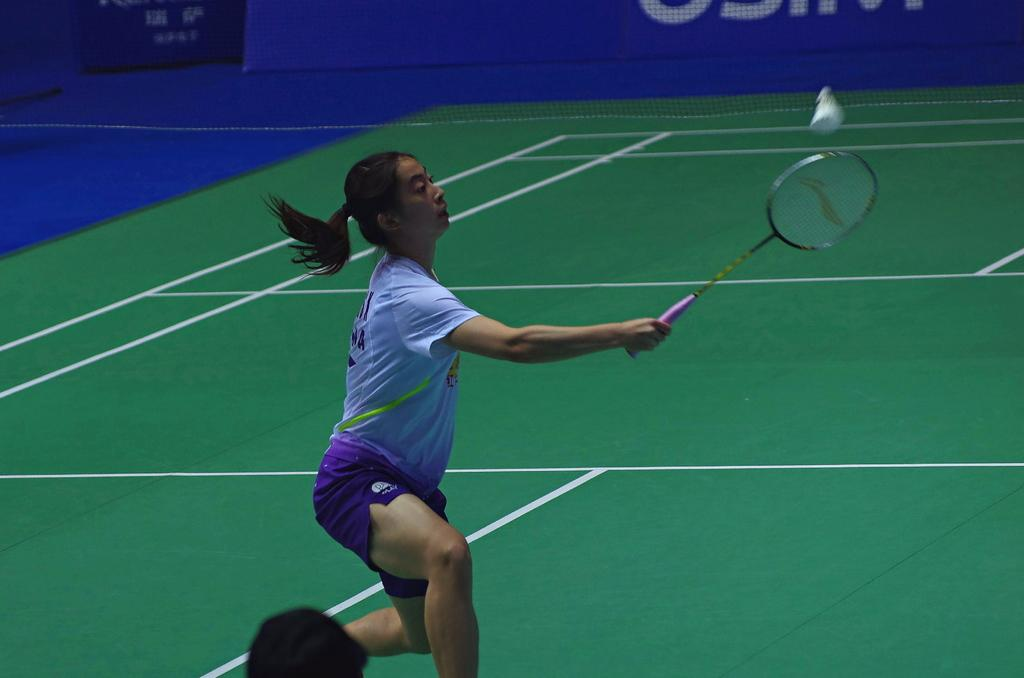How many people are in the image? There are two persons in the image. Can you describe one of the persons? One of the persons is a woman. What is the woman holding in the image? The woman is holding a badminton racket. What is happening with the shuttlecock in the image? A shuttlecock is in the air. What can be seen in the background of the image? There is a net visible in the background of the image. What type of lace is being used to decorate the peace sign in the image? There is no peace sign or lace present in the image. 